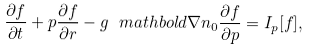<formula> <loc_0><loc_0><loc_500><loc_500>\frac { \partial f } { \partial t } + { p } \frac { \partial f } { \partial { r } } - g \ m a t h b o l d { \nabla } n _ { 0 } \frac { \partial f } { \partial { p } } = I _ { p } [ f ] ,</formula> 